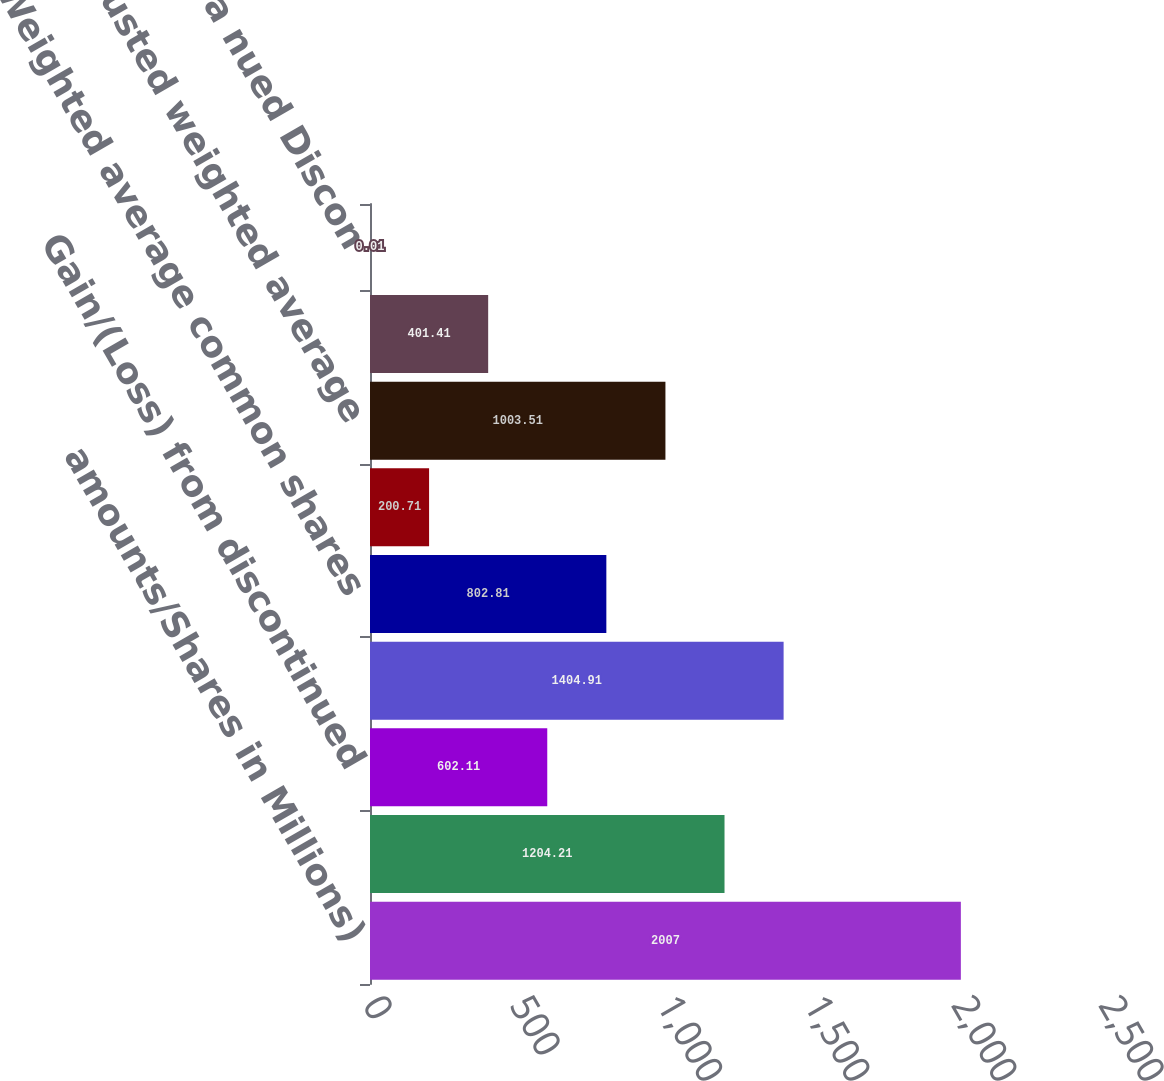Convert chart. <chart><loc_0><loc_0><loc_500><loc_500><bar_chart><fcel>amounts/Shares in Millions)<fcel>Income from continuing<fcel>Gain/(Loss) from discontinued<fcel>income Net<fcel>Weighted average common shares<fcel>Add Incremental shares<fcel>Adjusted weighted average<fcel>ons opera nuing Con<fcel>ons opera nued Discon<nl><fcel>2007<fcel>1204.21<fcel>602.11<fcel>1404.91<fcel>802.81<fcel>200.71<fcel>1003.51<fcel>401.41<fcel>0.01<nl></chart> 